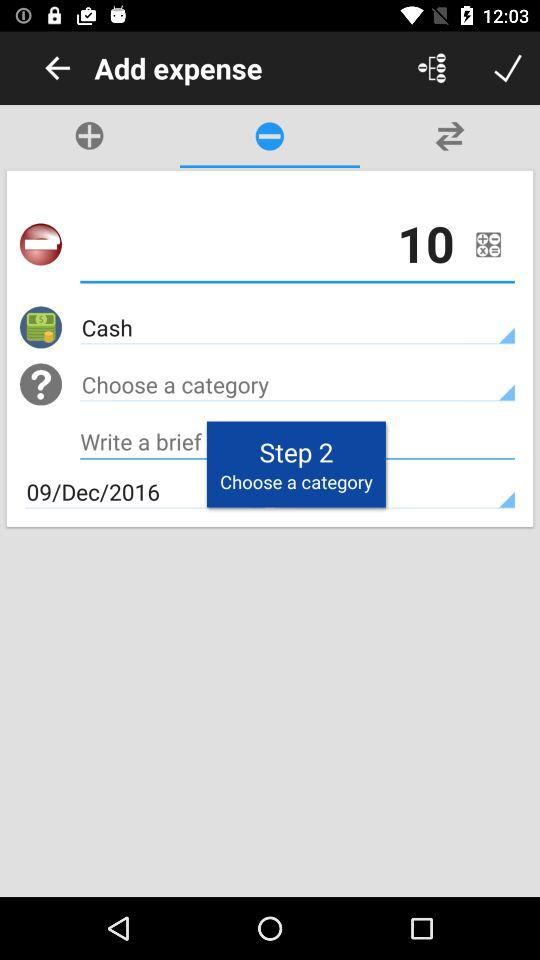What is the type of expense?
Answer the question using a single word or phrase. Cash 